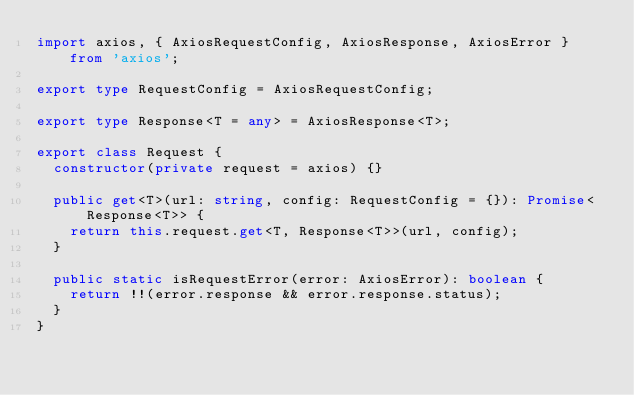Convert code to text. <code><loc_0><loc_0><loc_500><loc_500><_TypeScript_>import axios, { AxiosRequestConfig, AxiosResponse, AxiosError } from 'axios';

export type RequestConfig = AxiosRequestConfig;

export type Response<T = any> = AxiosResponse<T>;

export class Request {
  constructor(private request = axios) {}

  public get<T>(url: string, config: RequestConfig = {}): Promise<Response<T>> {
    return this.request.get<T, Response<T>>(url, config);
  }

  public static isRequestError(error: AxiosError): boolean {
    return !!(error.response && error.response.status);
  }
}
</code> 